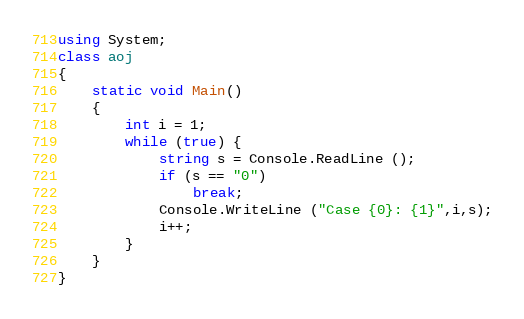Convert code to text. <code><loc_0><loc_0><loc_500><loc_500><_C#_>using System;
class aoj
{
	static void Main()
	{
		int i = 1;
		while (true) {
			string s = Console.ReadLine ();
			if (s == "0")
				break;
			Console.WriteLine ("Case {0}: {1}",i,s);
			i++;
		}
	}
}</code> 